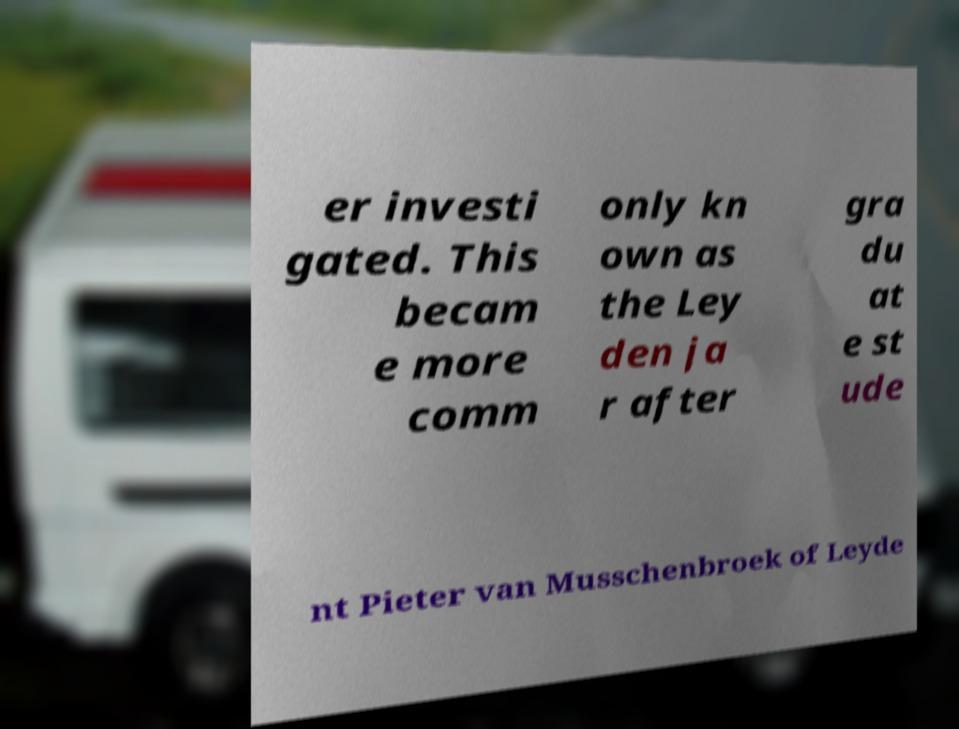Please read and relay the text visible in this image. What does it say? er investi gated. This becam e more comm only kn own as the Ley den ja r after gra du at e st ude nt Pieter van Musschenbroek of Leyde 